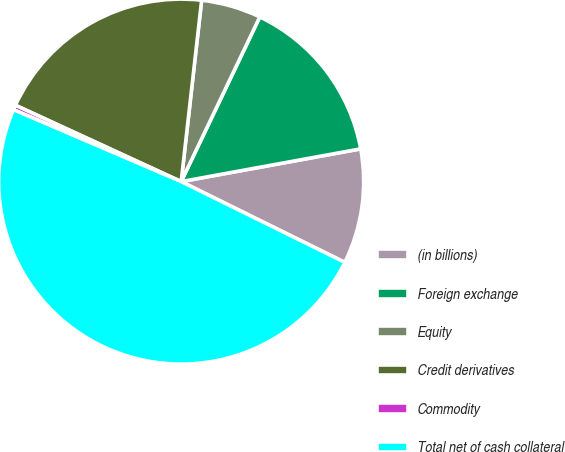<chart> <loc_0><loc_0><loc_500><loc_500><pie_chart><fcel>(in billions)<fcel>Foreign exchange<fcel>Equity<fcel>Credit derivatives<fcel>Commodity<fcel>Total net of cash collateral<nl><fcel>10.17%<fcel>15.04%<fcel>5.3%<fcel>19.92%<fcel>0.42%<fcel>49.15%<nl></chart> 